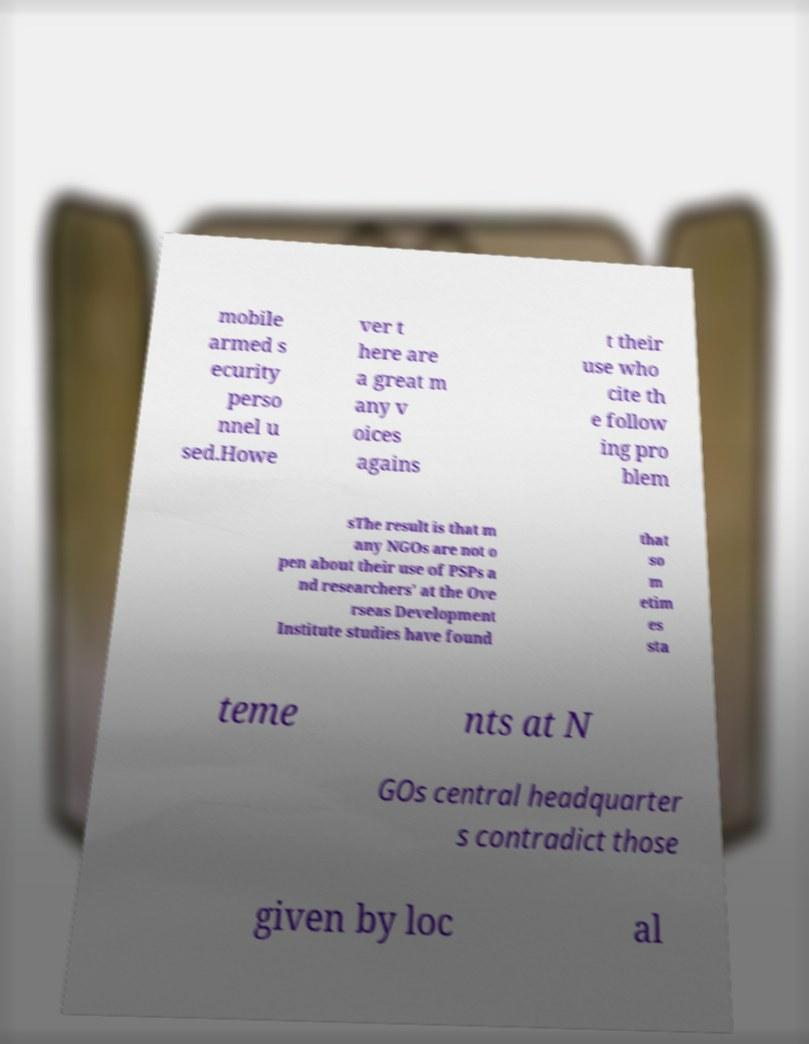Can you accurately transcribe the text from the provided image for me? mobile armed s ecurity perso nnel u sed.Howe ver t here are a great m any v oices agains t their use who cite th e follow ing pro blem sThe result is that m any NGOs are not o pen about their use of PSPs a nd researchers' at the Ove rseas Development Institute studies have found that so m etim es sta teme nts at N GOs central headquarter s contradict those given by loc al 